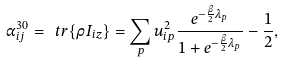Convert formula to latex. <formula><loc_0><loc_0><loc_500><loc_500>\alpha _ { i j } ^ { 3 0 } = \ t r { \{ \rho I _ { i z } \} } = \sum _ { p } u _ { i p } ^ { 2 } \frac { e ^ { - \frac { \beta } 2 \lambda _ { p } } } { 1 + e ^ { - \frac { \beta } 2 \lambda _ { p } } } - \frac { 1 } { 2 } ,</formula> 